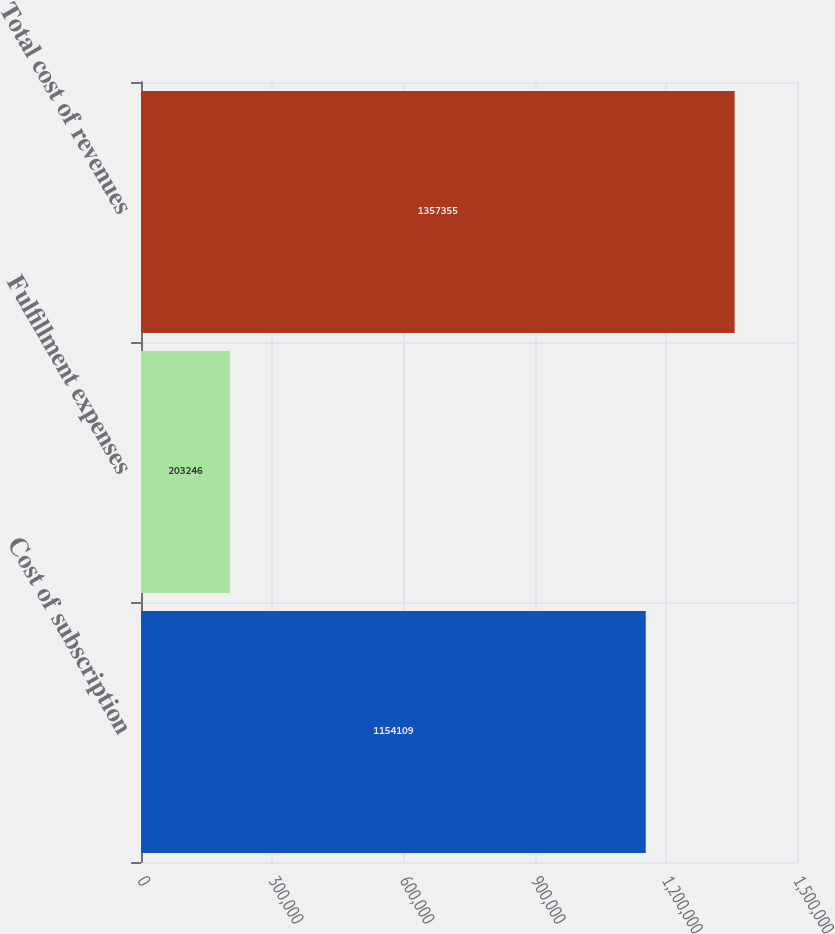Convert chart to OTSL. <chart><loc_0><loc_0><loc_500><loc_500><bar_chart><fcel>Cost of subscription<fcel>Fulfillment expenses<fcel>Total cost of revenues<nl><fcel>1.15411e+06<fcel>203246<fcel>1.35736e+06<nl></chart> 